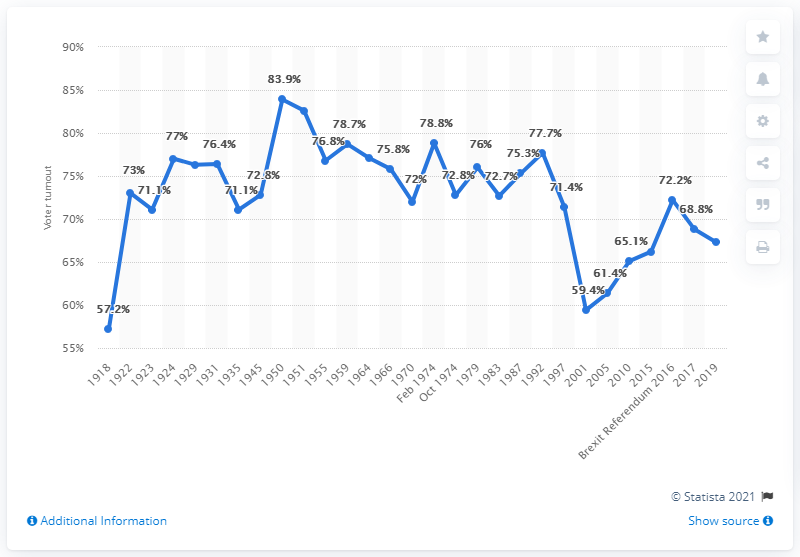List a handful of essential elements in this visual. The voter turnout in the 2016 Brexit Referendum was 72.2%. In the 2019 United Kingdom General Election, 67.3% of eligible voters cast their ballots. In 2001, the voter turnout was 59.4%. 